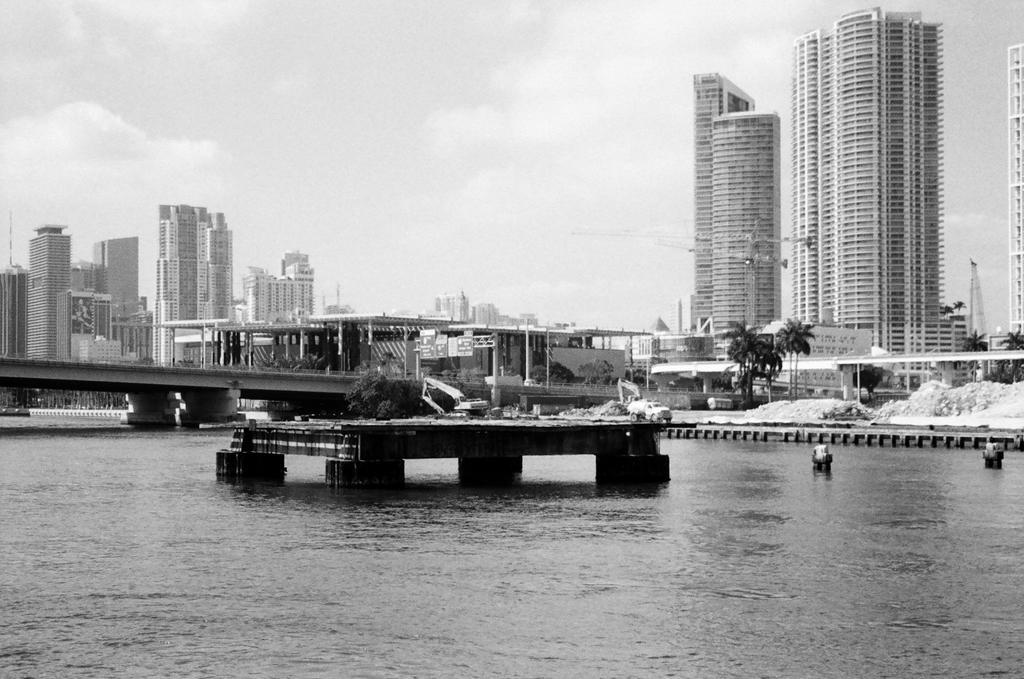How would you summarize this image in a sentence or two? In this image we can see some buildings, there is a bridge, there is a platform on the river, there are trees, also we can see the sky, and the picture is taken in black and white mode. 